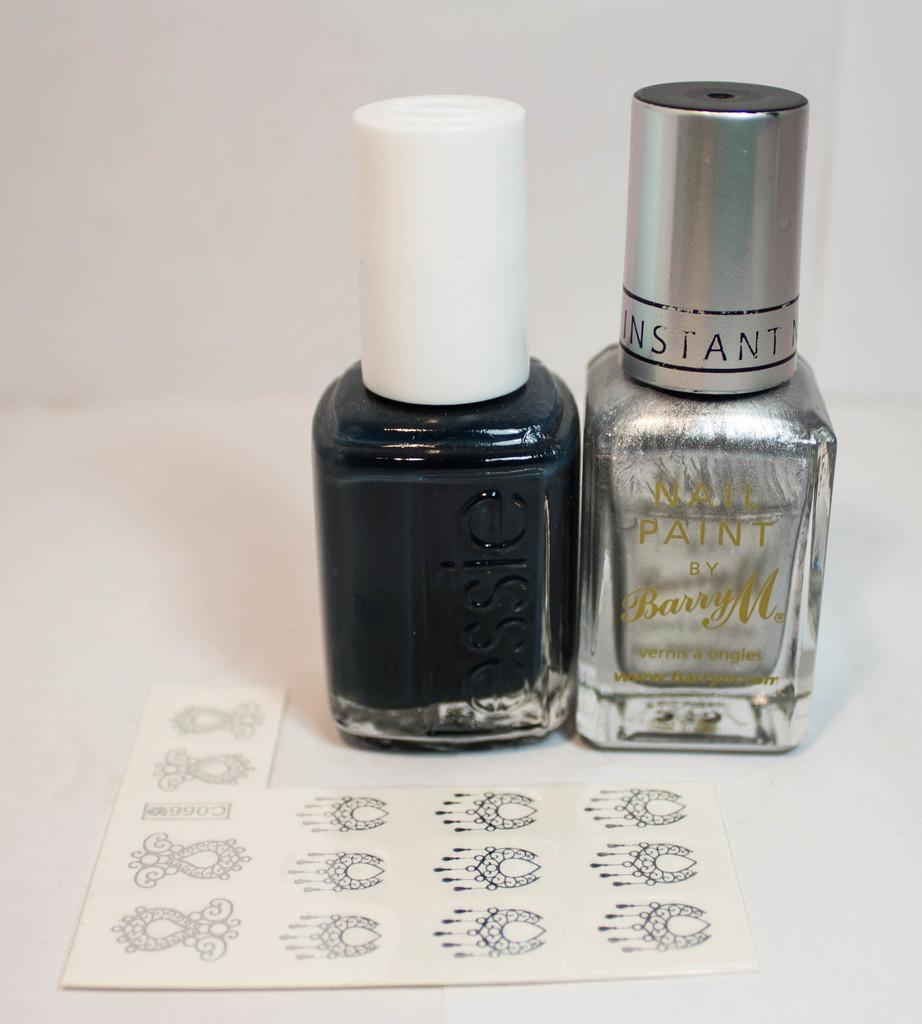<image>
Summarize the visual content of the image. A bottle of nail paint says "instant" on the cap and sits next to another bottle and some decals. 